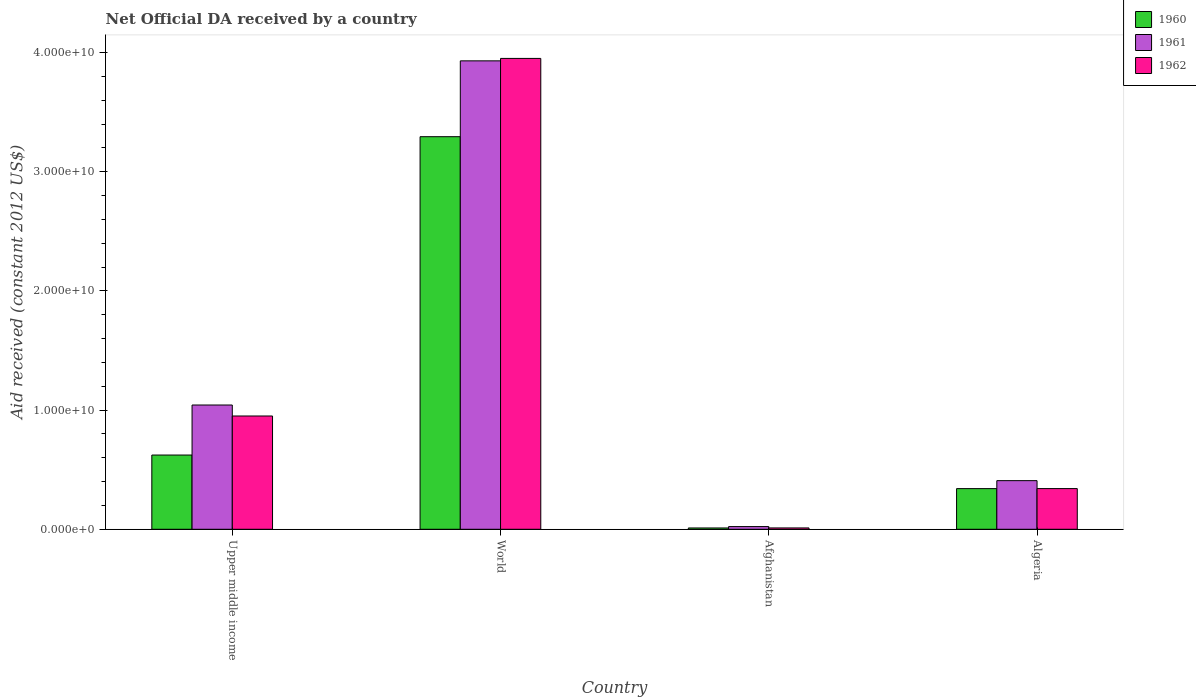How many groups of bars are there?
Ensure brevity in your answer.  4. Are the number of bars on each tick of the X-axis equal?
Your answer should be very brief. Yes. How many bars are there on the 4th tick from the left?
Ensure brevity in your answer.  3. What is the label of the 3rd group of bars from the left?
Your answer should be compact. Afghanistan. In how many cases, is the number of bars for a given country not equal to the number of legend labels?
Provide a succinct answer. 0. What is the net official development assistance aid received in 1960 in Upper middle income?
Your answer should be very brief. 6.23e+09. Across all countries, what is the maximum net official development assistance aid received in 1961?
Make the answer very short. 3.93e+1. Across all countries, what is the minimum net official development assistance aid received in 1961?
Your answer should be compact. 2.26e+08. In which country was the net official development assistance aid received in 1960 maximum?
Offer a very short reply. World. In which country was the net official development assistance aid received in 1962 minimum?
Make the answer very short. Afghanistan. What is the total net official development assistance aid received in 1962 in the graph?
Provide a short and direct response. 5.25e+1. What is the difference between the net official development assistance aid received in 1961 in Afghanistan and that in Upper middle income?
Offer a terse response. -1.02e+1. What is the difference between the net official development assistance aid received in 1961 in Algeria and the net official development assistance aid received in 1962 in World?
Your answer should be compact. -3.54e+1. What is the average net official development assistance aid received in 1960 per country?
Provide a short and direct response. 1.07e+1. What is the difference between the net official development assistance aid received of/in 1960 and net official development assistance aid received of/in 1961 in Afghanistan?
Provide a short and direct response. -1.16e+08. What is the ratio of the net official development assistance aid received in 1961 in Algeria to that in Upper middle income?
Give a very brief answer. 0.39. Is the difference between the net official development assistance aid received in 1960 in Afghanistan and World greater than the difference between the net official development assistance aid received in 1961 in Afghanistan and World?
Offer a terse response. Yes. What is the difference between the highest and the second highest net official development assistance aid received in 1962?
Provide a short and direct response. 3.00e+1. What is the difference between the highest and the lowest net official development assistance aid received in 1962?
Offer a terse response. 3.94e+1. In how many countries, is the net official development assistance aid received in 1962 greater than the average net official development assistance aid received in 1962 taken over all countries?
Offer a very short reply. 1. Is it the case that in every country, the sum of the net official development assistance aid received in 1960 and net official development assistance aid received in 1962 is greater than the net official development assistance aid received in 1961?
Offer a very short reply. No. How many bars are there?
Keep it short and to the point. 12. Are all the bars in the graph horizontal?
Your response must be concise. No. How many countries are there in the graph?
Your response must be concise. 4. Does the graph contain grids?
Offer a terse response. No. Where does the legend appear in the graph?
Offer a terse response. Top right. What is the title of the graph?
Your answer should be compact. Net Official DA received by a country. What is the label or title of the Y-axis?
Your response must be concise. Aid received (constant 2012 US$). What is the Aid received (constant 2012 US$) of 1960 in Upper middle income?
Offer a very short reply. 6.23e+09. What is the Aid received (constant 2012 US$) of 1961 in Upper middle income?
Your response must be concise. 1.04e+1. What is the Aid received (constant 2012 US$) of 1962 in Upper middle income?
Your answer should be compact. 9.51e+09. What is the Aid received (constant 2012 US$) in 1960 in World?
Ensure brevity in your answer.  3.29e+1. What is the Aid received (constant 2012 US$) in 1961 in World?
Offer a terse response. 3.93e+1. What is the Aid received (constant 2012 US$) in 1962 in World?
Your response must be concise. 3.95e+1. What is the Aid received (constant 2012 US$) in 1960 in Afghanistan?
Offer a very short reply. 1.10e+08. What is the Aid received (constant 2012 US$) of 1961 in Afghanistan?
Ensure brevity in your answer.  2.26e+08. What is the Aid received (constant 2012 US$) of 1962 in Afghanistan?
Your answer should be compact. 1.12e+08. What is the Aid received (constant 2012 US$) of 1960 in Algeria?
Keep it short and to the point. 3.41e+09. What is the Aid received (constant 2012 US$) in 1961 in Algeria?
Offer a terse response. 4.08e+09. What is the Aid received (constant 2012 US$) in 1962 in Algeria?
Provide a succinct answer. 3.41e+09. Across all countries, what is the maximum Aid received (constant 2012 US$) of 1960?
Make the answer very short. 3.29e+1. Across all countries, what is the maximum Aid received (constant 2012 US$) in 1961?
Keep it short and to the point. 3.93e+1. Across all countries, what is the maximum Aid received (constant 2012 US$) of 1962?
Keep it short and to the point. 3.95e+1. Across all countries, what is the minimum Aid received (constant 2012 US$) in 1960?
Make the answer very short. 1.10e+08. Across all countries, what is the minimum Aid received (constant 2012 US$) in 1961?
Your response must be concise. 2.26e+08. Across all countries, what is the minimum Aid received (constant 2012 US$) of 1962?
Provide a short and direct response. 1.12e+08. What is the total Aid received (constant 2012 US$) of 1960 in the graph?
Ensure brevity in your answer.  4.27e+1. What is the total Aid received (constant 2012 US$) in 1961 in the graph?
Your answer should be compact. 5.40e+1. What is the total Aid received (constant 2012 US$) in 1962 in the graph?
Provide a succinct answer. 5.25e+1. What is the difference between the Aid received (constant 2012 US$) in 1960 in Upper middle income and that in World?
Your answer should be very brief. -2.67e+1. What is the difference between the Aid received (constant 2012 US$) of 1961 in Upper middle income and that in World?
Offer a terse response. -2.89e+1. What is the difference between the Aid received (constant 2012 US$) of 1962 in Upper middle income and that in World?
Your answer should be very brief. -3.00e+1. What is the difference between the Aid received (constant 2012 US$) of 1960 in Upper middle income and that in Afghanistan?
Offer a terse response. 6.12e+09. What is the difference between the Aid received (constant 2012 US$) of 1961 in Upper middle income and that in Afghanistan?
Keep it short and to the point. 1.02e+1. What is the difference between the Aid received (constant 2012 US$) of 1962 in Upper middle income and that in Afghanistan?
Your response must be concise. 9.39e+09. What is the difference between the Aid received (constant 2012 US$) in 1960 in Upper middle income and that in Algeria?
Give a very brief answer. 2.82e+09. What is the difference between the Aid received (constant 2012 US$) of 1961 in Upper middle income and that in Algeria?
Your answer should be compact. 6.35e+09. What is the difference between the Aid received (constant 2012 US$) in 1962 in Upper middle income and that in Algeria?
Offer a very short reply. 6.09e+09. What is the difference between the Aid received (constant 2012 US$) in 1960 in World and that in Afghanistan?
Give a very brief answer. 3.28e+1. What is the difference between the Aid received (constant 2012 US$) in 1961 in World and that in Afghanistan?
Give a very brief answer. 3.91e+1. What is the difference between the Aid received (constant 2012 US$) in 1962 in World and that in Afghanistan?
Provide a succinct answer. 3.94e+1. What is the difference between the Aid received (constant 2012 US$) of 1960 in World and that in Algeria?
Make the answer very short. 2.95e+1. What is the difference between the Aid received (constant 2012 US$) of 1961 in World and that in Algeria?
Offer a terse response. 3.52e+1. What is the difference between the Aid received (constant 2012 US$) in 1962 in World and that in Algeria?
Provide a succinct answer. 3.61e+1. What is the difference between the Aid received (constant 2012 US$) of 1960 in Afghanistan and that in Algeria?
Give a very brief answer. -3.30e+09. What is the difference between the Aid received (constant 2012 US$) of 1961 in Afghanistan and that in Algeria?
Ensure brevity in your answer.  -3.85e+09. What is the difference between the Aid received (constant 2012 US$) in 1962 in Afghanistan and that in Algeria?
Your answer should be compact. -3.30e+09. What is the difference between the Aid received (constant 2012 US$) in 1960 in Upper middle income and the Aid received (constant 2012 US$) in 1961 in World?
Make the answer very short. -3.31e+1. What is the difference between the Aid received (constant 2012 US$) in 1960 in Upper middle income and the Aid received (constant 2012 US$) in 1962 in World?
Offer a terse response. -3.33e+1. What is the difference between the Aid received (constant 2012 US$) of 1961 in Upper middle income and the Aid received (constant 2012 US$) of 1962 in World?
Your response must be concise. -2.91e+1. What is the difference between the Aid received (constant 2012 US$) of 1960 in Upper middle income and the Aid received (constant 2012 US$) of 1961 in Afghanistan?
Your response must be concise. 6.00e+09. What is the difference between the Aid received (constant 2012 US$) of 1960 in Upper middle income and the Aid received (constant 2012 US$) of 1962 in Afghanistan?
Provide a succinct answer. 6.12e+09. What is the difference between the Aid received (constant 2012 US$) of 1961 in Upper middle income and the Aid received (constant 2012 US$) of 1962 in Afghanistan?
Offer a very short reply. 1.03e+1. What is the difference between the Aid received (constant 2012 US$) of 1960 in Upper middle income and the Aid received (constant 2012 US$) of 1961 in Algeria?
Your answer should be compact. 2.15e+09. What is the difference between the Aid received (constant 2012 US$) in 1960 in Upper middle income and the Aid received (constant 2012 US$) in 1962 in Algeria?
Offer a very short reply. 2.82e+09. What is the difference between the Aid received (constant 2012 US$) in 1961 in Upper middle income and the Aid received (constant 2012 US$) in 1962 in Algeria?
Ensure brevity in your answer.  7.01e+09. What is the difference between the Aid received (constant 2012 US$) of 1960 in World and the Aid received (constant 2012 US$) of 1961 in Afghanistan?
Your answer should be very brief. 3.27e+1. What is the difference between the Aid received (constant 2012 US$) in 1960 in World and the Aid received (constant 2012 US$) in 1962 in Afghanistan?
Provide a succinct answer. 3.28e+1. What is the difference between the Aid received (constant 2012 US$) of 1961 in World and the Aid received (constant 2012 US$) of 1962 in Afghanistan?
Keep it short and to the point. 3.92e+1. What is the difference between the Aid received (constant 2012 US$) of 1960 in World and the Aid received (constant 2012 US$) of 1961 in Algeria?
Keep it short and to the point. 2.89e+1. What is the difference between the Aid received (constant 2012 US$) of 1960 in World and the Aid received (constant 2012 US$) of 1962 in Algeria?
Provide a short and direct response. 2.95e+1. What is the difference between the Aid received (constant 2012 US$) in 1961 in World and the Aid received (constant 2012 US$) in 1962 in Algeria?
Your answer should be compact. 3.59e+1. What is the difference between the Aid received (constant 2012 US$) in 1960 in Afghanistan and the Aid received (constant 2012 US$) in 1961 in Algeria?
Keep it short and to the point. -3.97e+09. What is the difference between the Aid received (constant 2012 US$) in 1960 in Afghanistan and the Aid received (constant 2012 US$) in 1962 in Algeria?
Provide a succinct answer. -3.30e+09. What is the difference between the Aid received (constant 2012 US$) in 1961 in Afghanistan and the Aid received (constant 2012 US$) in 1962 in Algeria?
Offer a very short reply. -3.19e+09. What is the average Aid received (constant 2012 US$) of 1960 per country?
Your response must be concise. 1.07e+1. What is the average Aid received (constant 2012 US$) of 1961 per country?
Your response must be concise. 1.35e+1. What is the average Aid received (constant 2012 US$) in 1962 per country?
Give a very brief answer. 1.31e+1. What is the difference between the Aid received (constant 2012 US$) in 1960 and Aid received (constant 2012 US$) in 1961 in Upper middle income?
Make the answer very short. -4.20e+09. What is the difference between the Aid received (constant 2012 US$) in 1960 and Aid received (constant 2012 US$) in 1962 in Upper middle income?
Keep it short and to the point. -3.28e+09. What is the difference between the Aid received (constant 2012 US$) in 1961 and Aid received (constant 2012 US$) in 1962 in Upper middle income?
Keep it short and to the point. 9.22e+08. What is the difference between the Aid received (constant 2012 US$) of 1960 and Aid received (constant 2012 US$) of 1961 in World?
Your answer should be compact. -6.36e+09. What is the difference between the Aid received (constant 2012 US$) of 1960 and Aid received (constant 2012 US$) of 1962 in World?
Offer a terse response. -6.57e+09. What is the difference between the Aid received (constant 2012 US$) in 1961 and Aid received (constant 2012 US$) in 1962 in World?
Provide a short and direct response. -2.05e+08. What is the difference between the Aid received (constant 2012 US$) in 1960 and Aid received (constant 2012 US$) in 1961 in Afghanistan?
Your response must be concise. -1.16e+08. What is the difference between the Aid received (constant 2012 US$) in 1960 and Aid received (constant 2012 US$) in 1962 in Afghanistan?
Keep it short and to the point. -2.63e+06. What is the difference between the Aid received (constant 2012 US$) in 1961 and Aid received (constant 2012 US$) in 1962 in Afghanistan?
Offer a terse response. 1.13e+08. What is the difference between the Aid received (constant 2012 US$) of 1960 and Aid received (constant 2012 US$) of 1961 in Algeria?
Give a very brief answer. -6.69e+08. What is the difference between the Aid received (constant 2012 US$) in 1960 and Aid received (constant 2012 US$) in 1962 in Algeria?
Ensure brevity in your answer.  -2.85e+06. What is the difference between the Aid received (constant 2012 US$) in 1961 and Aid received (constant 2012 US$) in 1962 in Algeria?
Give a very brief answer. 6.66e+08. What is the ratio of the Aid received (constant 2012 US$) of 1960 in Upper middle income to that in World?
Provide a short and direct response. 0.19. What is the ratio of the Aid received (constant 2012 US$) of 1961 in Upper middle income to that in World?
Give a very brief answer. 0.27. What is the ratio of the Aid received (constant 2012 US$) of 1962 in Upper middle income to that in World?
Ensure brevity in your answer.  0.24. What is the ratio of the Aid received (constant 2012 US$) in 1960 in Upper middle income to that in Afghanistan?
Give a very brief answer. 56.73. What is the ratio of the Aid received (constant 2012 US$) in 1961 in Upper middle income to that in Afghanistan?
Give a very brief answer. 46.2. What is the ratio of the Aid received (constant 2012 US$) of 1962 in Upper middle income to that in Afghanistan?
Keep it short and to the point. 84.54. What is the ratio of the Aid received (constant 2012 US$) in 1960 in Upper middle income to that in Algeria?
Provide a succinct answer. 1.83. What is the ratio of the Aid received (constant 2012 US$) of 1961 in Upper middle income to that in Algeria?
Keep it short and to the point. 2.56. What is the ratio of the Aid received (constant 2012 US$) of 1962 in Upper middle income to that in Algeria?
Offer a very short reply. 2.78. What is the ratio of the Aid received (constant 2012 US$) of 1960 in World to that in Afghanistan?
Provide a succinct answer. 300.02. What is the ratio of the Aid received (constant 2012 US$) of 1961 in World to that in Afghanistan?
Ensure brevity in your answer.  174.12. What is the ratio of the Aid received (constant 2012 US$) in 1962 in World to that in Afghanistan?
Provide a succinct answer. 351.41. What is the ratio of the Aid received (constant 2012 US$) of 1960 in World to that in Algeria?
Provide a succinct answer. 9.66. What is the ratio of the Aid received (constant 2012 US$) of 1961 in World to that in Algeria?
Ensure brevity in your answer.  9.63. What is the ratio of the Aid received (constant 2012 US$) of 1962 in World to that in Algeria?
Provide a succinct answer. 11.57. What is the ratio of the Aid received (constant 2012 US$) of 1960 in Afghanistan to that in Algeria?
Your answer should be very brief. 0.03. What is the ratio of the Aid received (constant 2012 US$) of 1961 in Afghanistan to that in Algeria?
Provide a short and direct response. 0.06. What is the ratio of the Aid received (constant 2012 US$) of 1962 in Afghanistan to that in Algeria?
Offer a terse response. 0.03. What is the difference between the highest and the second highest Aid received (constant 2012 US$) of 1960?
Keep it short and to the point. 2.67e+1. What is the difference between the highest and the second highest Aid received (constant 2012 US$) of 1961?
Keep it short and to the point. 2.89e+1. What is the difference between the highest and the second highest Aid received (constant 2012 US$) in 1962?
Provide a short and direct response. 3.00e+1. What is the difference between the highest and the lowest Aid received (constant 2012 US$) of 1960?
Give a very brief answer. 3.28e+1. What is the difference between the highest and the lowest Aid received (constant 2012 US$) in 1961?
Make the answer very short. 3.91e+1. What is the difference between the highest and the lowest Aid received (constant 2012 US$) in 1962?
Ensure brevity in your answer.  3.94e+1. 